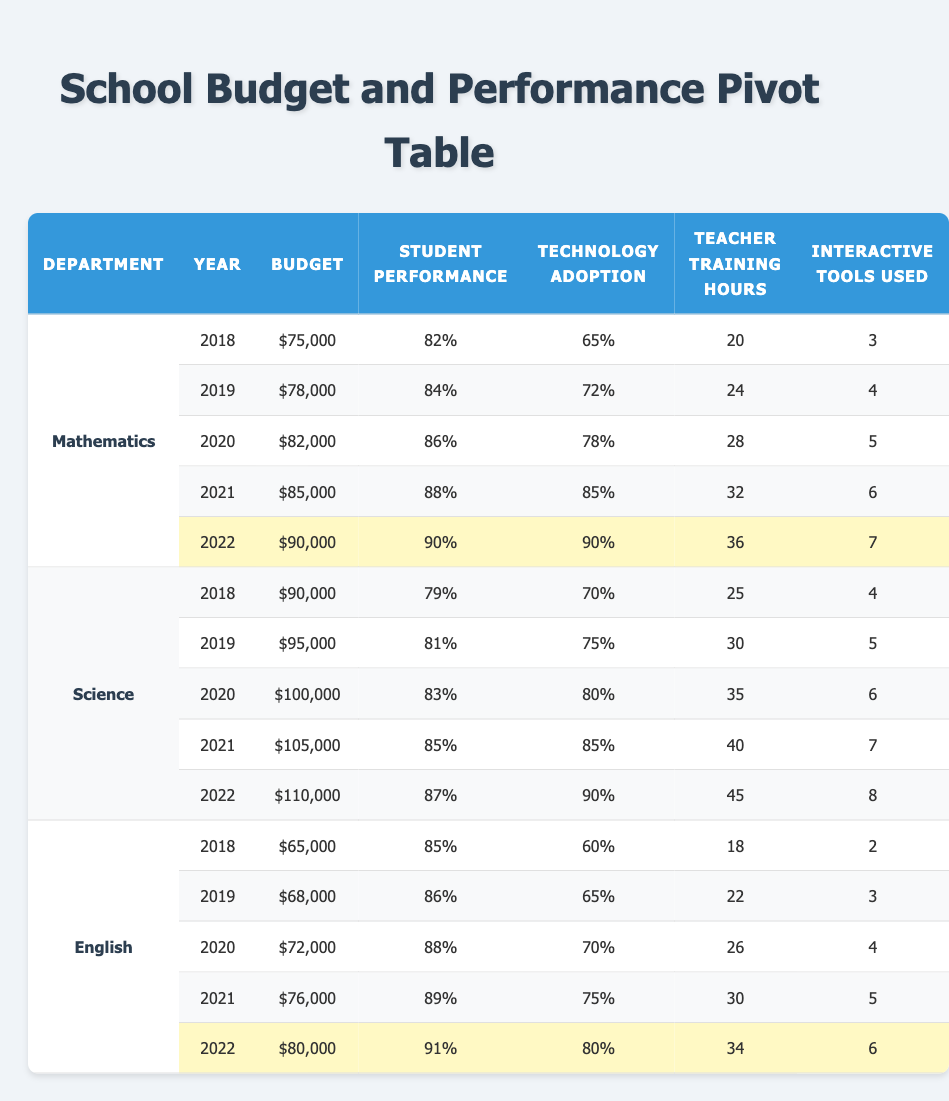What was the budget allocated for the English department in 2020? In 2020, the English department's budget is listed in the row with the year 2020 under the English heading, which shows $72,000.
Answer: $72,000 Which year saw the highest student performance in Mathematics? Looking through the rows for the Mathematics department, the highest student performance is in 2022, where it is listed as 90%.
Answer: 2022 What was the average budget allocated to the Science department over the five years? The budgets for Science from 2018 to 2022 are $90,000, $95,000, $100,000, $105,000, and $110,000. Summing these values gives $500,000, and dividing by 5 gives an average of $100,000.
Answer: $100,000 Is the Technology Adoption for the English department in 2022 greater than 80%? From the English department row corresponding to 2022, the Technology Adoption is listed as 80%, which is not greater than 80%.
Answer: No In which year did the Science department have the lowest Teacher Training Hours, and how many hours were recorded? Scanning through the rows for the Science department, 2018 has 25 Teacher Training Hours, which is lower than the hours recorded for all other years (30, 35, 40, 45).
Answer: 2018, 25 hours What is the difference in Student Performance between Mathematics and English in 2021? In 2021, Mathematics had a student performance of 88%, and English had a performance of 89%. The difference is 89 - 88 = 1%.
Answer: 1% Over the five years, what percentage increase in budget did the Mathematics department experience? The budget for Mathematics started at $75,000 in 2018 and increased to $90,000 in 2022. The increase is $90,000 - $75,000 = $15,000. To find the percentage increase: (15,000 / 75,000) * 100 = 20%.
Answer: 20% Was there more than one year where the student performance in Science was below 85%? Reviewing the student performance for Science, only the years 2018 and 2019 had values below 85%, which makes it true that there was more than one year.
Answer: Yes 